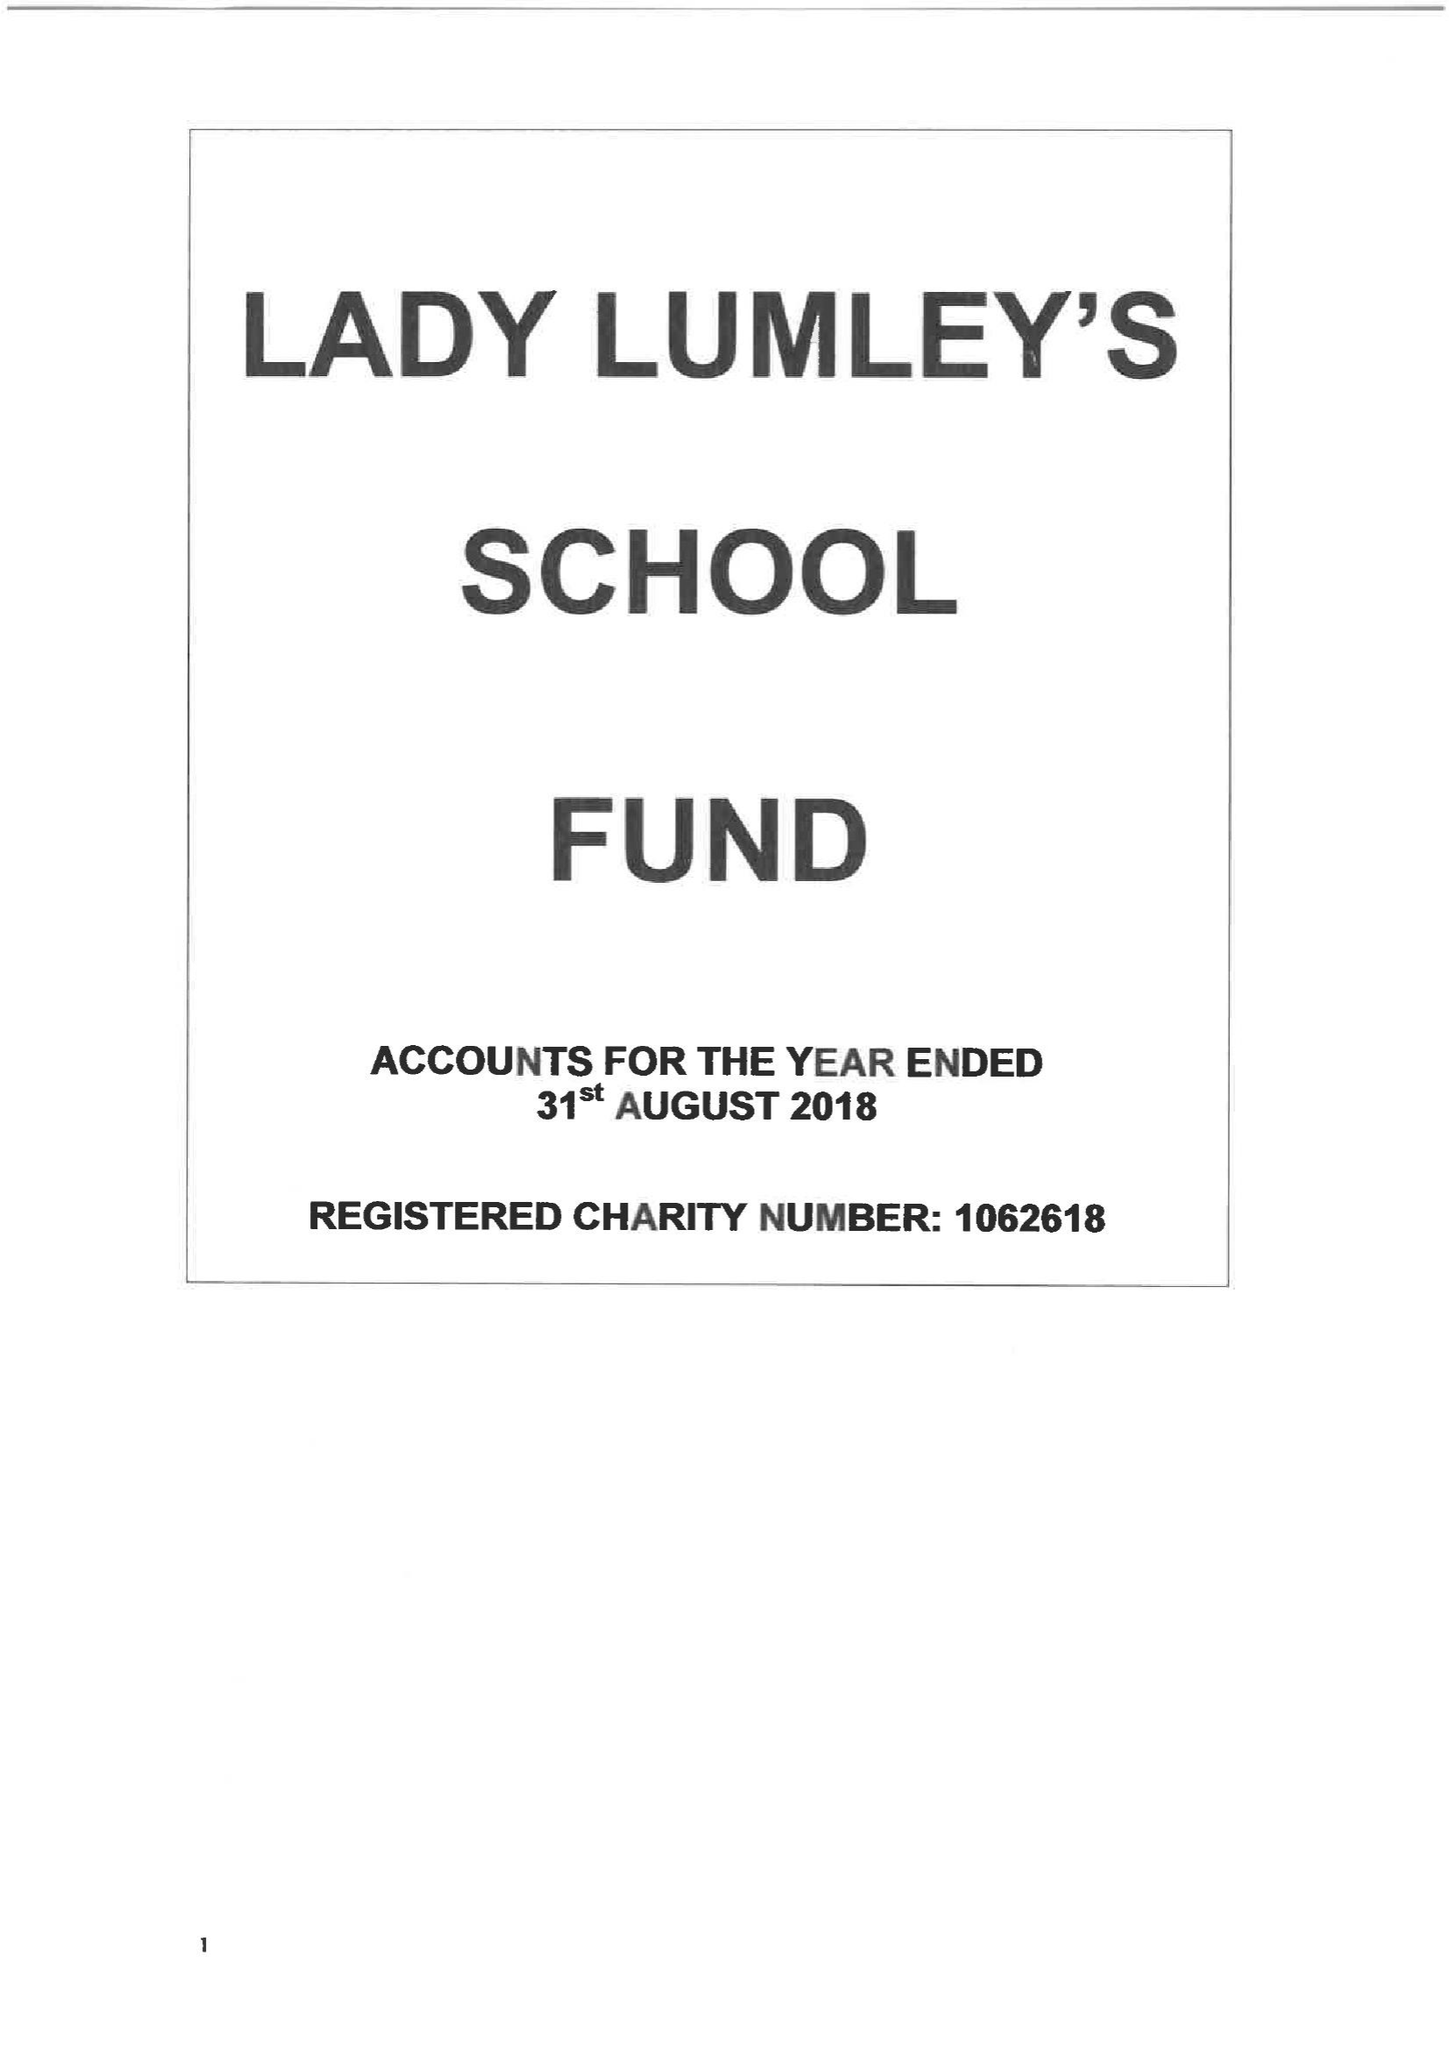What is the value for the address__post_town?
Answer the question using a single word or phrase. PICKERING 